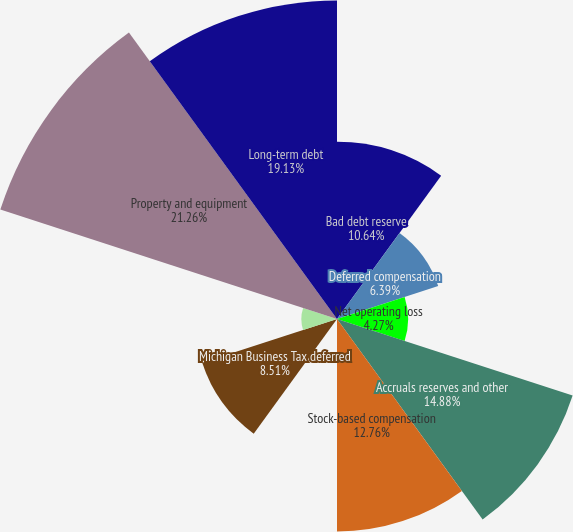Convert chart. <chart><loc_0><loc_0><loc_500><loc_500><pie_chart><fcel>Bad debt reserve<fcel>Deferred compensation<fcel>Net operating loss<fcel>Accruals reserves and other<fcel>Stock-based compensation<fcel>Tax credits<fcel>Michigan Business Tax deferred<fcel>Less Valuation allowance<fcel>Property and equipment<fcel>Long-term debt<nl><fcel>10.64%<fcel>6.39%<fcel>4.27%<fcel>14.88%<fcel>12.76%<fcel>0.02%<fcel>8.51%<fcel>2.14%<fcel>21.26%<fcel>19.13%<nl></chart> 